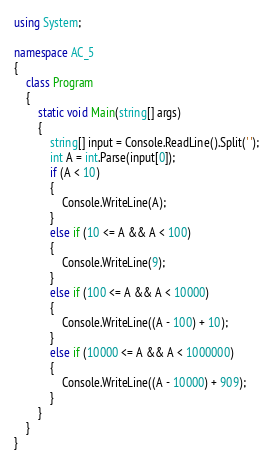<code> <loc_0><loc_0><loc_500><loc_500><_C#_>using System;

namespace AC_5
{
    class Program
    {
        static void Main(string[] args)
        {
            string[] input = Console.ReadLine().Split(' ');
            int A = int.Parse(input[0]);
            if (A < 10)
            {
                Console.WriteLine(A);
            }
            else if (10 <= A && A < 100)
            {
                Console.WriteLine(9);
            }
            else if (100 <= A && A < 10000)
            {
                Console.WriteLine((A - 100) + 10);
            }
            else if (10000 <= A && A < 1000000)
            {
                Console.WriteLine((A - 10000) + 909);
            }
        }
    }
}</code> 